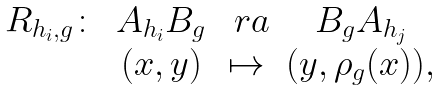<formula> <loc_0><loc_0><loc_500><loc_500>\begin{array} { c c c c } R _ { h _ { i } , g } \colon & A _ { h _ { i } } B _ { g } & \ r a & B _ { g } A _ { h _ { j } } \\ & ( x , y ) & \mapsto & ( y , \rho _ { g } ( x ) ) , \end{array}</formula> 